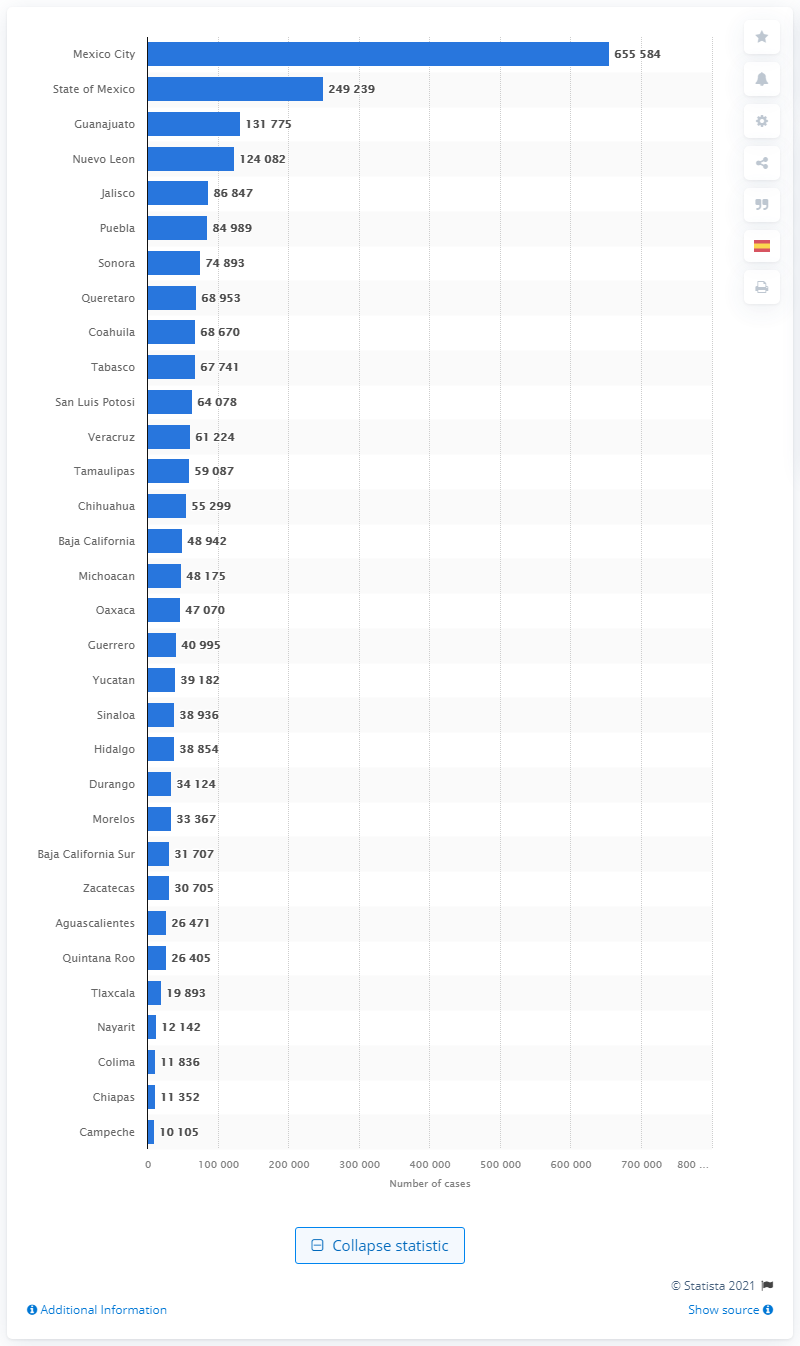Specify some key components in this picture. By the end of May, 2021, there had been a total of 655584 COVID-19 cases reported. 